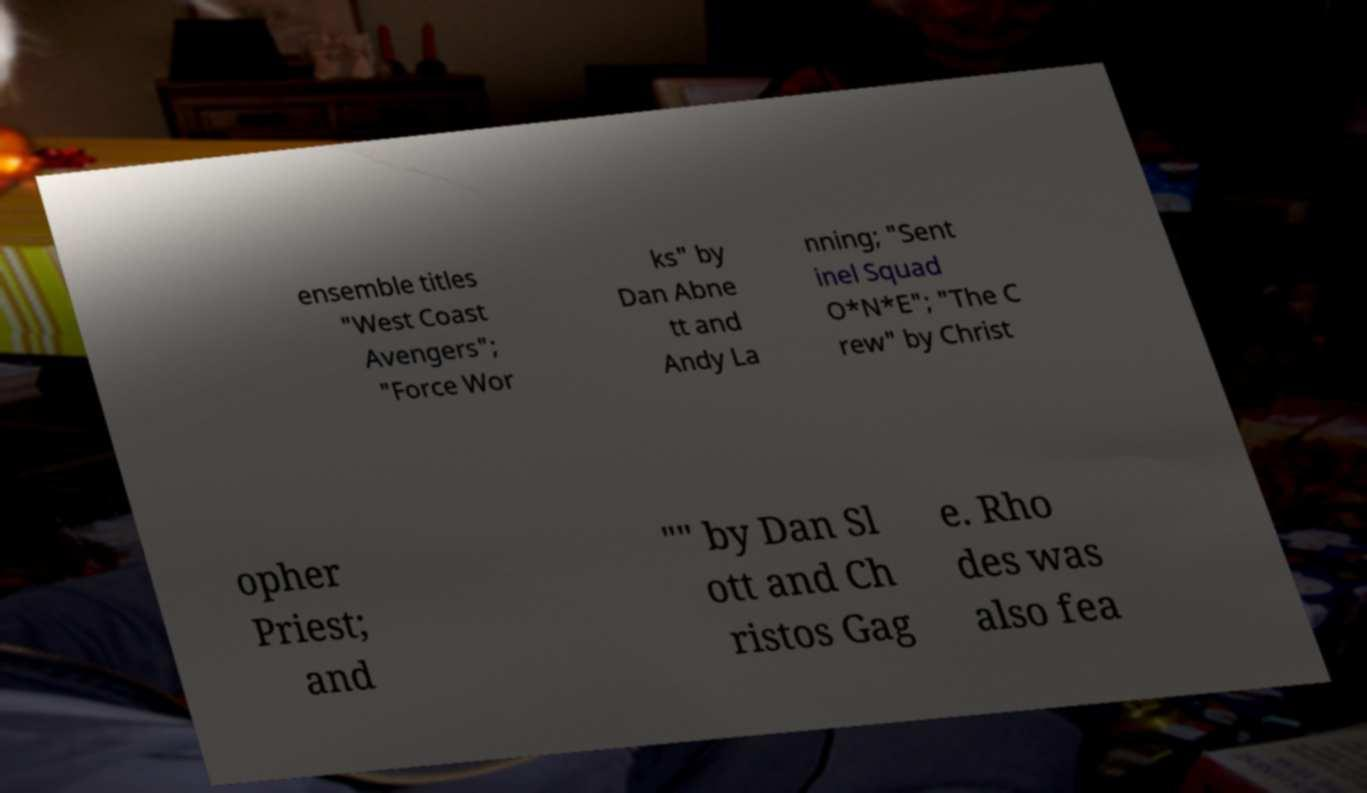Can you read and provide the text displayed in the image?This photo seems to have some interesting text. Can you extract and type it out for me? ensemble titles "West Coast Avengers"; "Force Wor ks" by Dan Abne tt and Andy La nning; "Sent inel Squad O*N*E"; "The C rew" by Christ opher Priest; and "" by Dan Sl ott and Ch ristos Gag e. Rho des was also fea 